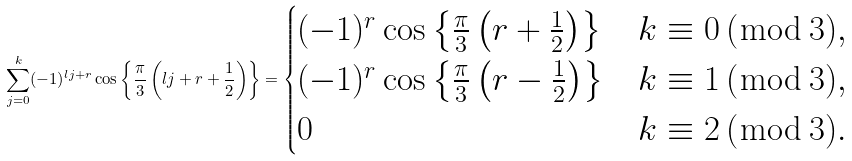Convert formula to latex. <formula><loc_0><loc_0><loc_500><loc_500>\sum _ { j = 0 } ^ { k } ( - 1 ) ^ { l j + r } \cos \left \{ \frac { \pi } { 3 } \left ( l j + r + \frac { 1 } { 2 } \right ) \right \} = \begin{cases} ( - 1 ) ^ { r } \cos \left \{ \frac { \pi } { 3 } \left ( r + \frac { 1 } { 2 } \right ) \right \} & k \equiv 0 \, ( \bmod \, 3 ) , \\ ( - 1 ) ^ { r } \cos \left \{ \frac { \pi } { 3 } \left ( r - \frac { 1 } { 2 } \right ) \right \} & k \equiv 1 \, ( \bmod \, 3 ) , \\ 0 & k \equiv 2 \, ( \bmod \, 3 ) . \end{cases}</formula> 